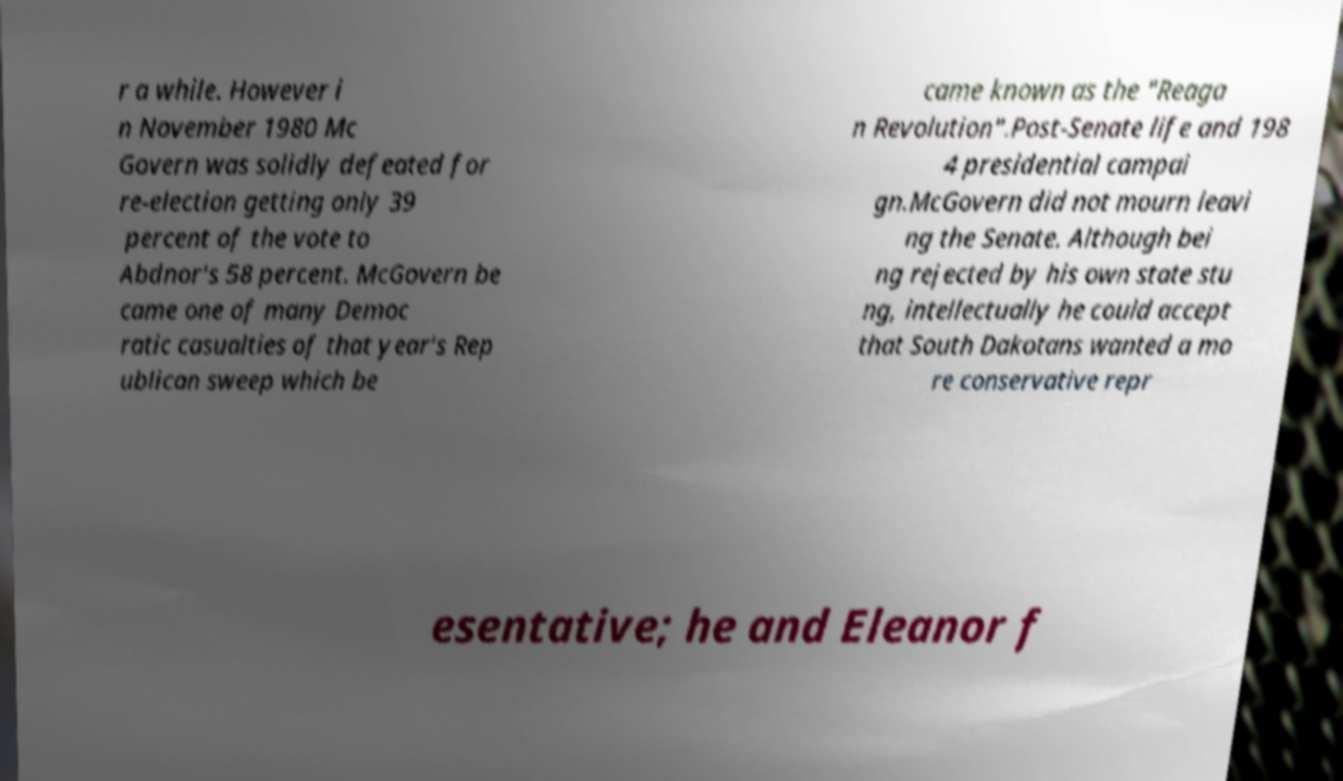What messages or text are displayed in this image? I need them in a readable, typed format. r a while. However i n November 1980 Mc Govern was solidly defeated for re-election getting only 39 percent of the vote to Abdnor's 58 percent. McGovern be came one of many Democ ratic casualties of that year's Rep ublican sweep which be came known as the "Reaga n Revolution".Post-Senate life and 198 4 presidential campai gn.McGovern did not mourn leavi ng the Senate. Although bei ng rejected by his own state stu ng, intellectually he could accept that South Dakotans wanted a mo re conservative repr esentative; he and Eleanor f 